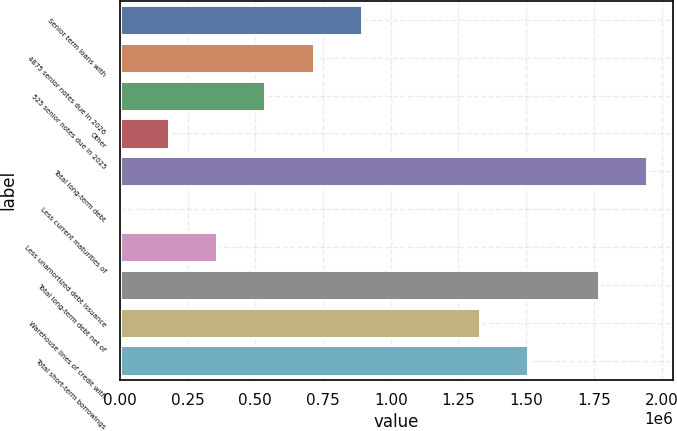<chart> <loc_0><loc_0><loc_500><loc_500><bar_chart><fcel>Senior term loans with<fcel>4875 senior notes due in 2026<fcel>525 senior notes due in 2025<fcel>Other<fcel>Total long-term debt<fcel>Less current maturities of<fcel>Less unamortized debt issuance<fcel>Total long-term debt net of<fcel>Warehouse lines of credit with<fcel>Total short-term borrowings<nl><fcel>894034<fcel>715856<fcel>537678<fcel>181324<fcel>1.94544e+06<fcel>3146<fcel>359501<fcel>1.76726e+06<fcel>1.32876e+06<fcel>1.50694e+06<nl></chart> 